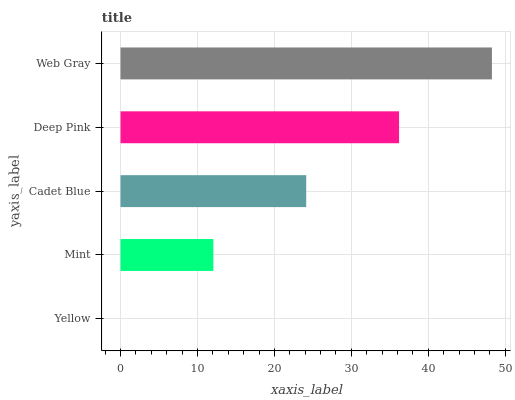Is Yellow the minimum?
Answer yes or no. Yes. Is Web Gray the maximum?
Answer yes or no. Yes. Is Mint the minimum?
Answer yes or no. No. Is Mint the maximum?
Answer yes or no. No. Is Mint greater than Yellow?
Answer yes or no. Yes. Is Yellow less than Mint?
Answer yes or no. Yes. Is Yellow greater than Mint?
Answer yes or no. No. Is Mint less than Yellow?
Answer yes or no. No. Is Cadet Blue the high median?
Answer yes or no. Yes. Is Cadet Blue the low median?
Answer yes or no. Yes. Is Web Gray the high median?
Answer yes or no. No. Is Yellow the low median?
Answer yes or no. No. 